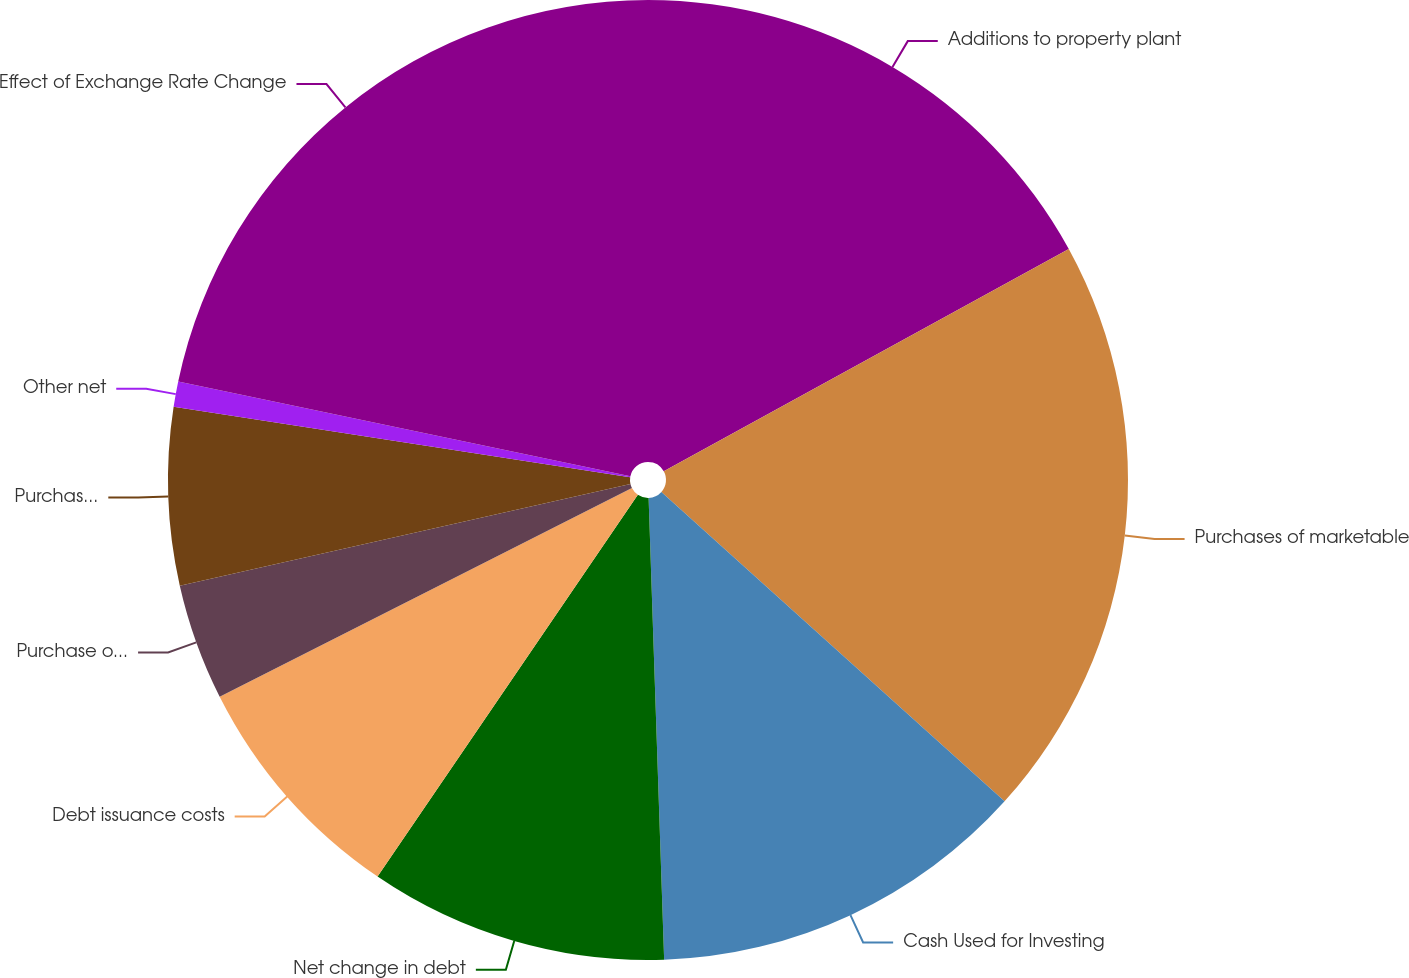Convert chart to OTSL. <chart><loc_0><loc_0><loc_500><loc_500><pie_chart><fcel>Additions to property plant<fcel>Purchases of marketable<fcel>Cash Used for Investing<fcel>Net change in debt<fcel>Debt issuance costs<fcel>Purchase of redeemable<fcel>Purchases of Tyson Class A<fcel>Other net<fcel>Effect of Exchange Rate Change<nl><fcel>17.01%<fcel>19.66%<fcel>12.79%<fcel>10.06%<fcel>8.02%<fcel>3.92%<fcel>5.97%<fcel>0.85%<fcel>21.71%<nl></chart> 